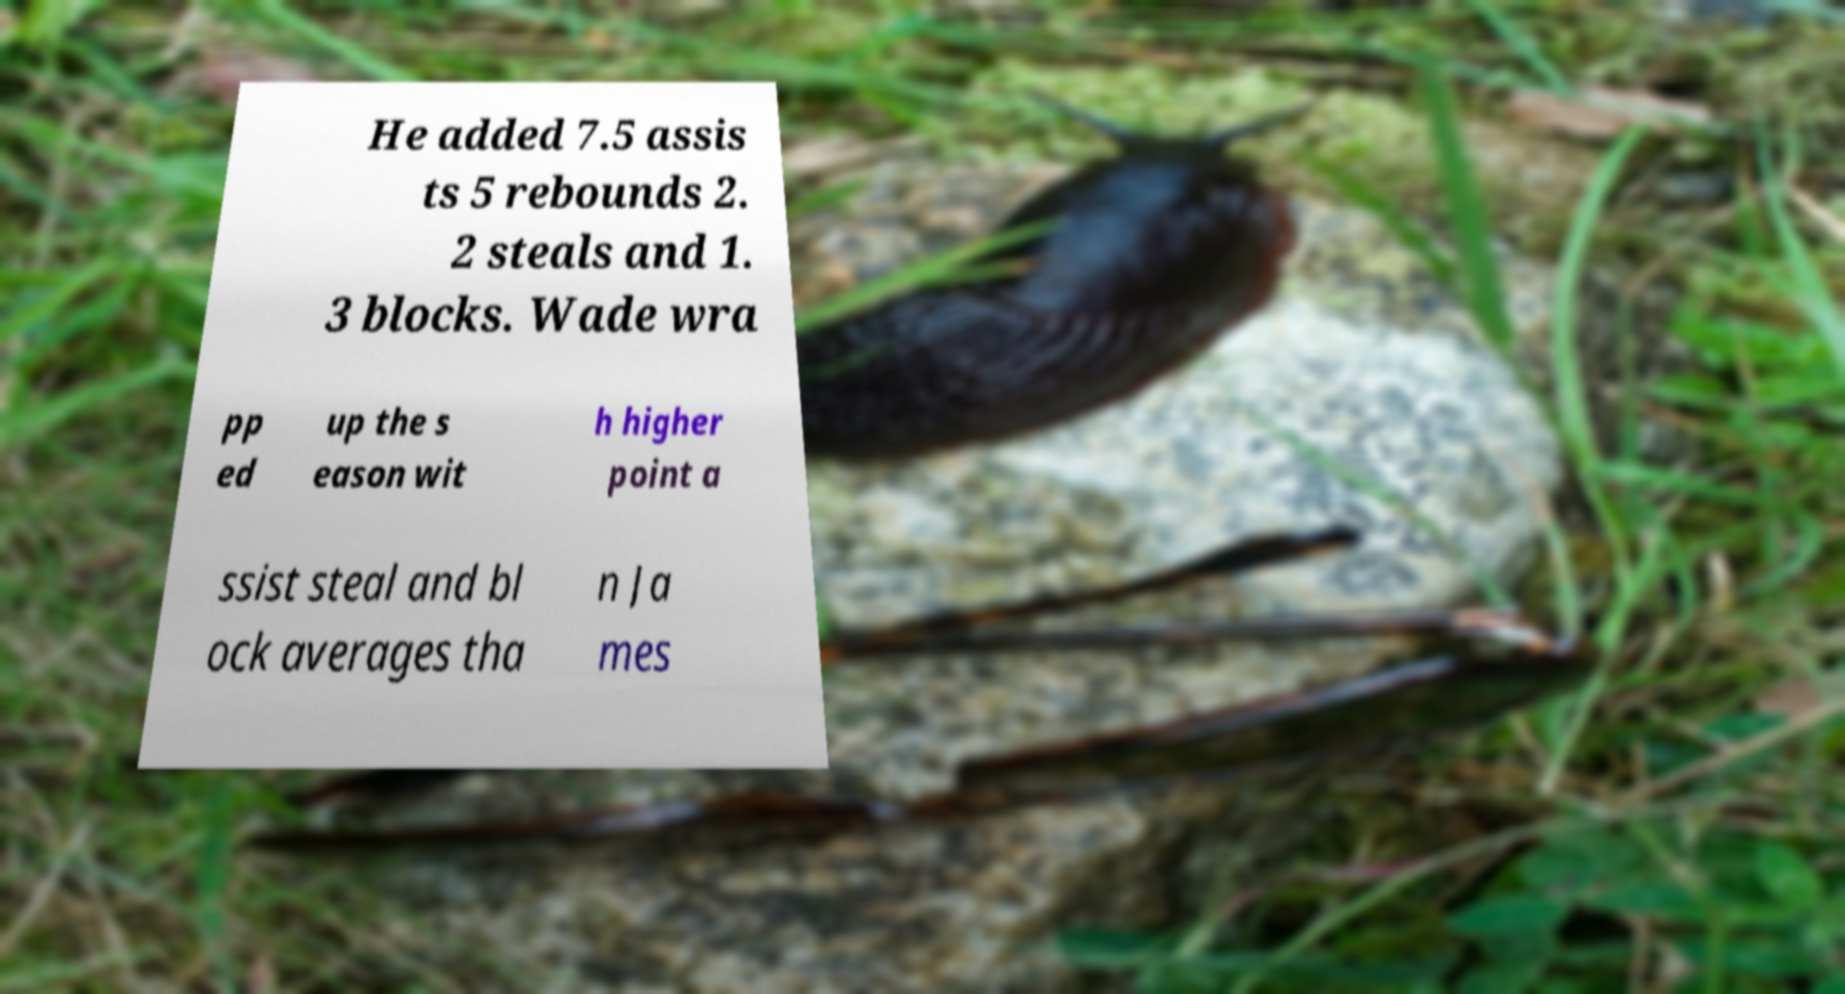Could you extract and type out the text from this image? He added 7.5 assis ts 5 rebounds 2. 2 steals and 1. 3 blocks. Wade wra pp ed up the s eason wit h higher point a ssist steal and bl ock averages tha n Ja mes 